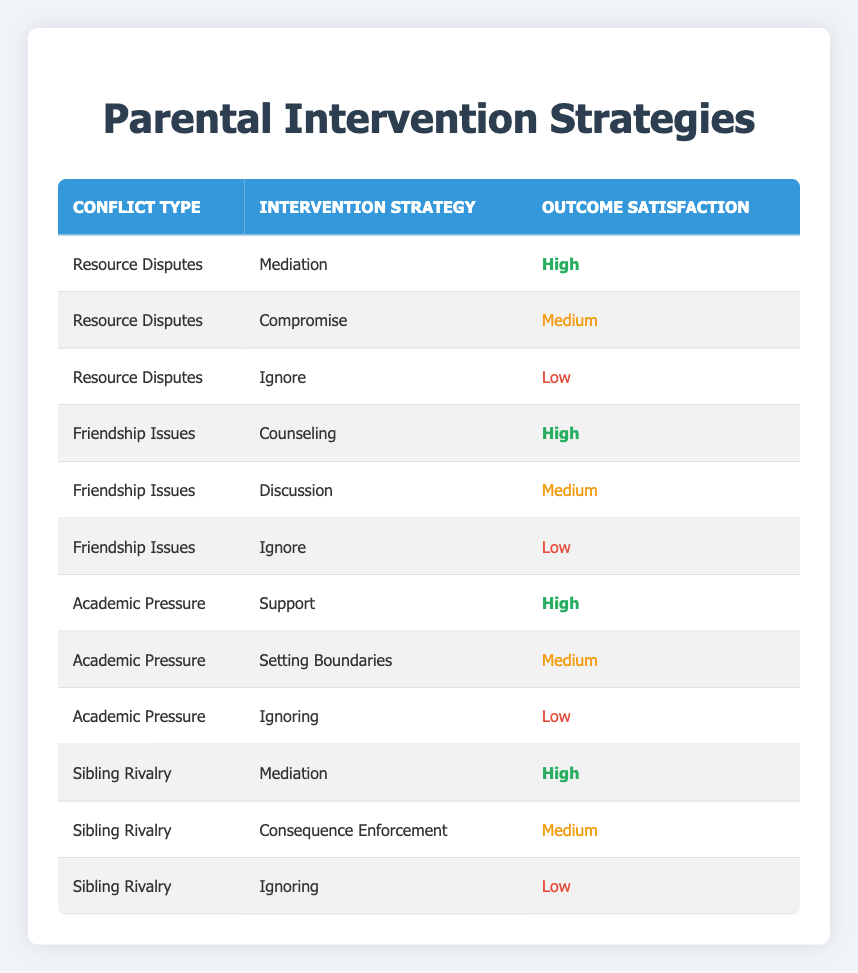What is the highest outcome satisfaction level achieved for Resource Disputes? The table shows that the outcome satisfaction level for Resource Disputes under the Mediation strategy is classified as High. No other outcomes are higher than this, thus Mediation represents the highest satisfaction level for this type of conflict.
Answer: High Which intervention strategy yields a Medium outcome satisfaction for Academic Pressure? From the table, the strategy listed for Academic Pressure that has a Medium outcome satisfaction is Setting Boundaries. The table explicitly states the corresponding satisfaction level for each strategy under this conflict type.
Answer: Setting Boundaries Is there any conflict type where the Ignore strategy results in a High satisfaction outcome? By reviewing the table, none of the conflict types where the Ignore strategy is used show a High satisfaction outcome. All entries for the Ignore strategy fall into the Low satisfaction category. Thus, the answer is no.
Answer: No How many total strategies lead to High outcome satisfaction across all conflict types? The table indicates three instances of High outcome satisfaction: Mediation for Resource Disputes, Counseling for Friendship Issues, and Support for Academic Pressure. Adding these gives a total of three strategies that lead to High satisfaction.
Answer: 3 Which conflict type has the least effective intervention strategy based on the outcome satisfaction? The least effective strategy across all conflict types can be identified as the Ignore strategy, as it results in Low satisfaction in all cases it is mentioned (Resource Disputes, Friendship Issues, Academic Pressure, Sibling Rivalry). Based on the data presented, this pattern shows it has the least effectiveness.
Answer: Ignore What is the average outcome satisfaction level for Sibling Rivalry? For Sibling Rivalry, the outcome satisfaction levels are High, Medium, and Low. Assigning numerical values (High = 3, Medium = 2, Low = 1), the average can be calculated as (3+2+1)/3 = 2. Thus, the average satisfaction outcome level is Medium.
Answer: Medium Using the same scale, what is the average outcome satisfaction across all conflict types? To find the average across all conflict types, we can list each outcome satisfaction level numerically: High = 3, Medium = 2, Low = 1. There are a total of 12 data points: 6 High, 4 Medium, and 2 Low. Thus, the average would be (6*3 + 4*2 + 2*1) / 12 = (18 + 8 + 2) / 12 = 28/12 = 2.33. This indicates the average is closer to Medium.
Answer: Medium Is the outcome satisfaction level for Counseling higher than that for Compromise? Checking the table, Counseling under Friendship Issues is classified as High, while Compromise under Resource Disputes is classified as Medium. Thus, Counseling has a higher satisfaction level than Compromise.
Answer: Yes 